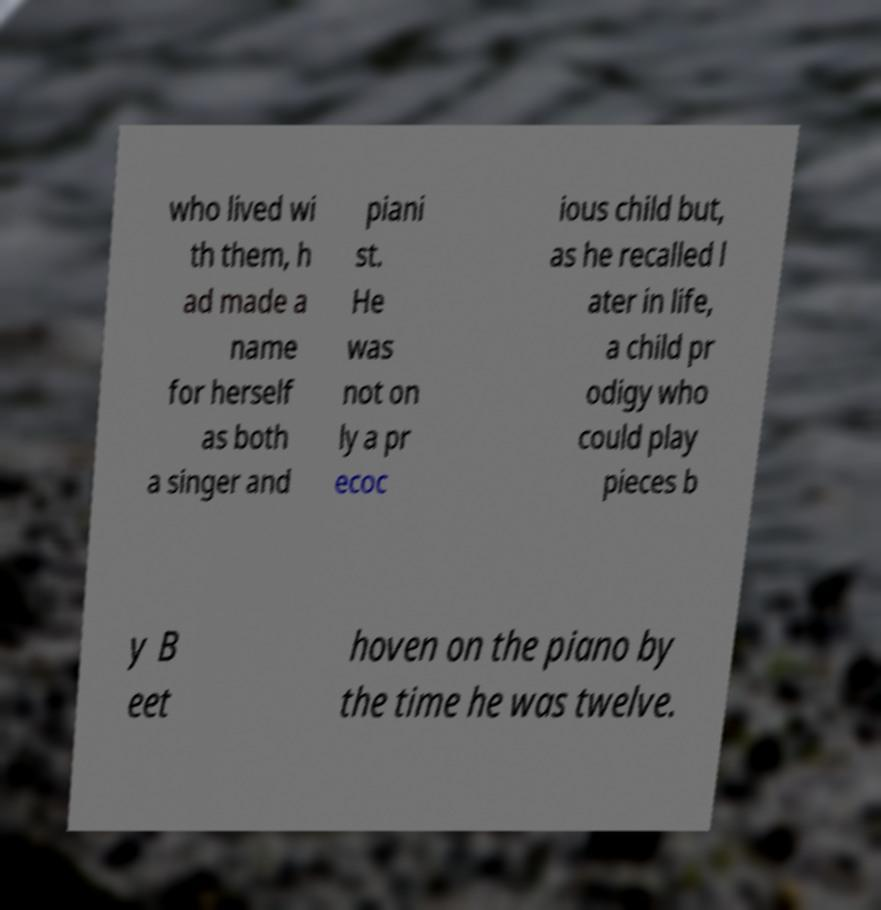Could you extract and type out the text from this image? who lived wi th them, h ad made a name for herself as both a singer and piani st. He was not on ly a pr ecoc ious child but, as he recalled l ater in life, a child pr odigy who could play pieces b y B eet hoven on the piano by the time he was twelve. 